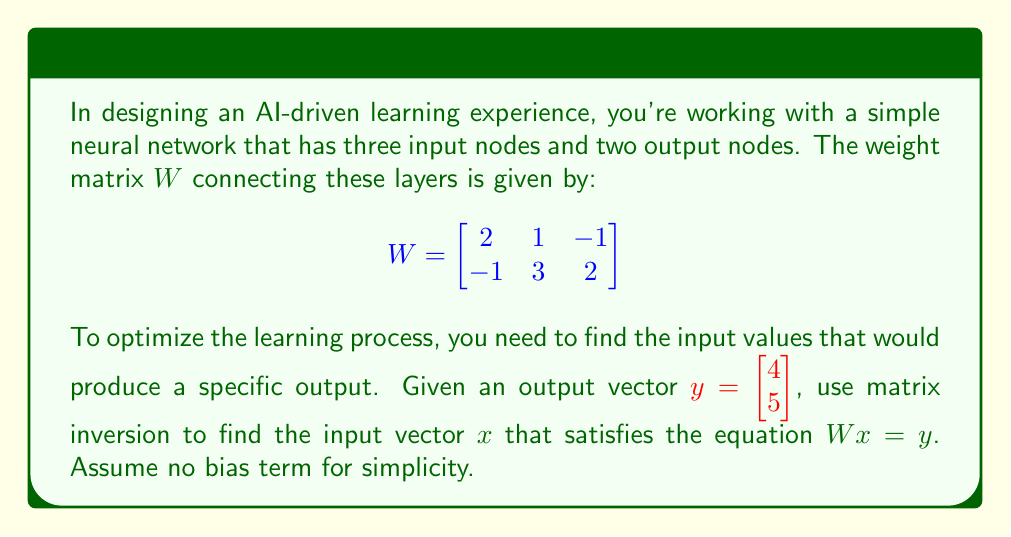Give your solution to this math problem. To solve this problem, we need to follow these steps:

1) First, we need to recognize that the equation $Wx = y$ cannot be directly solved by inverting $W$, as $W$ is not a square matrix. Instead, we need to use the left inverse of $W$.

2) The left inverse of $W$ is given by $(W^TW)^{-1}W^T$, where $W^T$ is the transpose of $W$.

3) Let's calculate $W^T$:

   $$W^T = \begin{bmatrix}
   2 & -1 \\
   1 & 3 \\
   -1 & 2
   \end{bmatrix}$$

4) Now, let's calculate $W^TW$:

   $$W^TW = \begin{bmatrix}
   2 & -1 \\
   1 & 3 \\
   -1 & 2
   \end{bmatrix} \begin{bmatrix}
   2 & 1 & -1 \\
   -1 & 3 & 2
   \end{bmatrix} = \begin{bmatrix}
   5 & -1 & -4 \\
   -1 & 10 & 7 \\
   -4 & 7 & 5
   \end{bmatrix}$$

5) Next, we need to find $(W^TW)^{-1}$. We can use the adjugate method:

   $$\det(W^TW) = 5(10\cdot5 - 7\cdot7) + (-1)(-1\cdot5 - (-4)\cdot7) + (-4)(-1\cdot7 - 10\cdot(-4)) = 1$$

   $$(W^TW)^{-1} = \frac{1}{\det(W^TW)} \begin{bmatrix}
   45 & -11 & -34 \\
   -11 & 30 & -19 \\
   -34 & -19 & 53
   \end{bmatrix} = \begin{bmatrix}
   45 & -11 & -34 \\
   -11 & 30 & -19 \\
   -34 & -19 & 53
   \end{bmatrix}$$

6) Now we can calculate the left inverse of $W$:

   $$(W^TW)^{-1}W^T = \begin{bmatrix}
   45 & -11 & -34 \\
   -11 & 30 & -19 \\
   -34 & -19 & 53
   \end{bmatrix} \begin{bmatrix}
   2 & -1 \\
   1 & 3 \\
   -1 & 2
   \end{bmatrix} = \begin{bmatrix}
   23 & -45 \\
   -7 & 15 \\
   -16 & 30
   \end{bmatrix}$$

7) Finally, we can solve for $x$:

   $$x = (W^TW)^{-1}W^T y = \begin{bmatrix}
   23 & -45 \\
   -7 & 15 \\
   -16 & 30
   \end{bmatrix} \begin{bmatrix}
   4 \\
   5
   \end{bmatrix} = \begin{bmatrix}
   23\cdot4 + (-45)\cdot5 \\
   (-7)\cdot4 + 15\cdot5 \\
   (-16)\cdot4 + 30\cdot5
   \end{bmatrix} = \begin{bmatrix}
   -133 \\
   47 \\
   86
   \end{bmatrix}$$
Answer: The input vector $x$ that satisfies $Wx = y$ is:

$$x = \begin{bmatrix}
-133 \\
47 \\
86
\end{bmatrix}$$ 